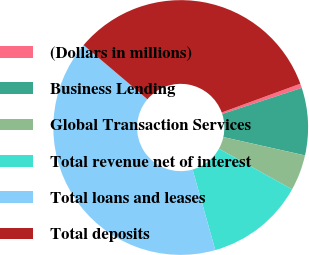<chart> <loc_0><loc_0><loc_500><loc_500><pie_chart><fcel>(Dollars in millions)<fcel>Business Lending<fcel>Global Transaction Services<fcel>Total revenue net of interest<fcel>Total loans and leases<fcel>Total deposits<nl><fcel>0.55%<fcel>8.55%<fcel>4.55%<fcel>12.56%<fcel>40.58%<fcel>33.22%<nl></chart> 